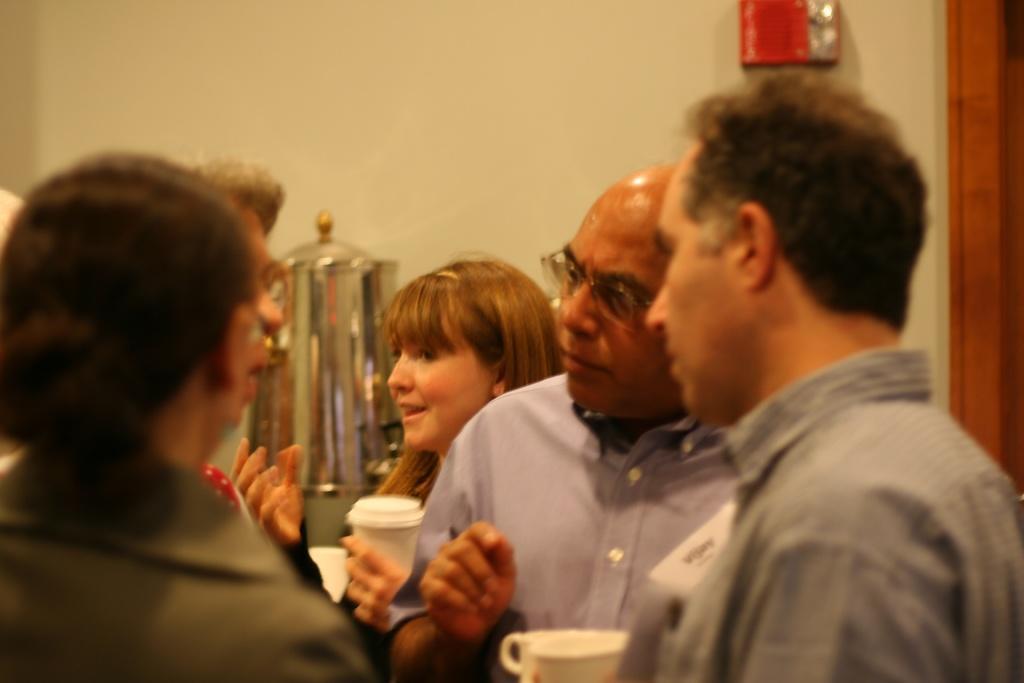Please provide a concise description of this image. In this image we can see a group of people. Two persons are holding cups in their hands. In the background, we can see a container and a box on the wall. 